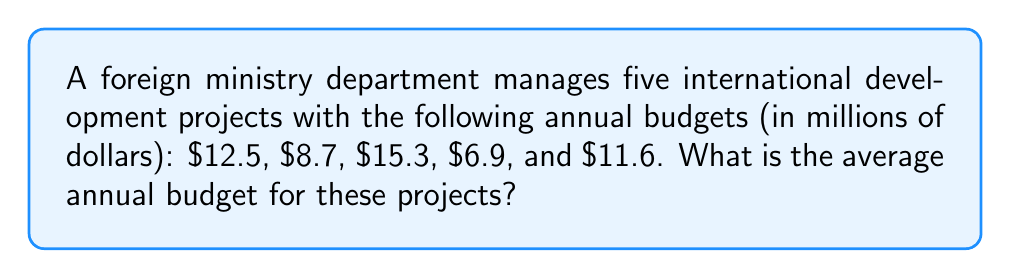Provide a solution to this math problem. To find the average annual budget, we need to:
1. Sum up all the budgets
2. Divide the sum by the number of projects

Step 1: Sum up all the budgets
$$12.5 + 8.7 + 15.3 + 6.9 + 11.6 = 55$$

Step 2: Divide the sum by the number of projects (5)
$$\frac{55}{5} = 11$$

Therefore, the average annual budget for these international development projects is $11 million.
Answer: $11 million 